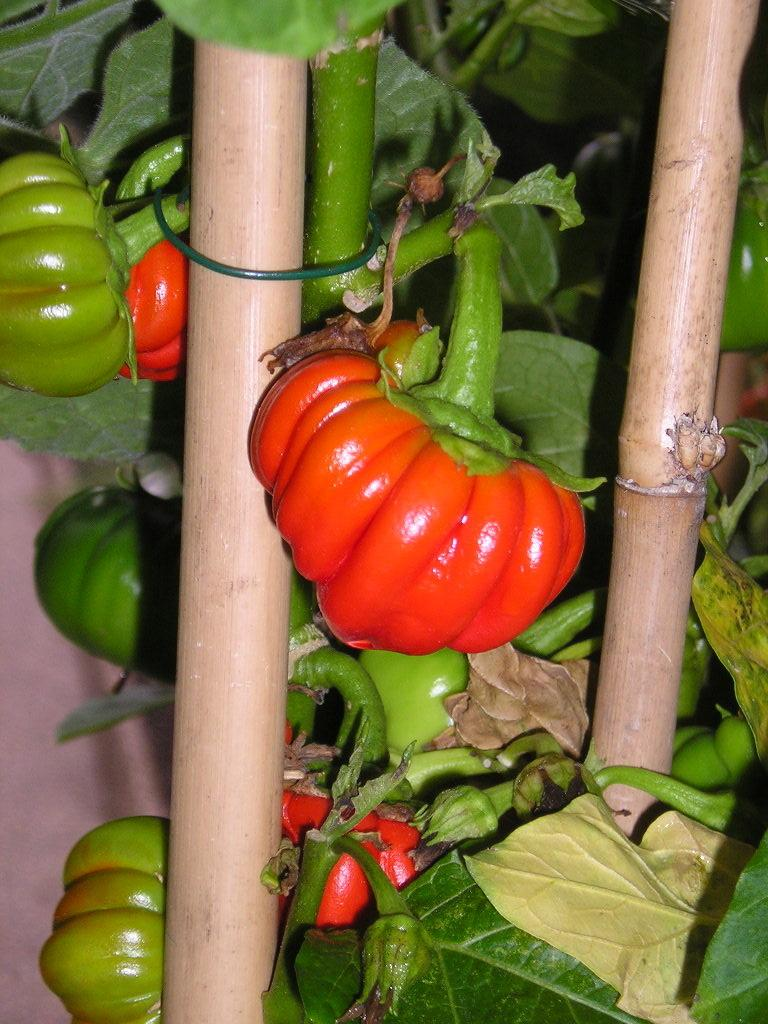What type of plant material is present in the image? There are leaves in the image. What type of edible plant material is present in the image? There are vegetables in the image. What type of rest can be seen in the image? There is no rest present in the image; it only features leaves and vegetables. 